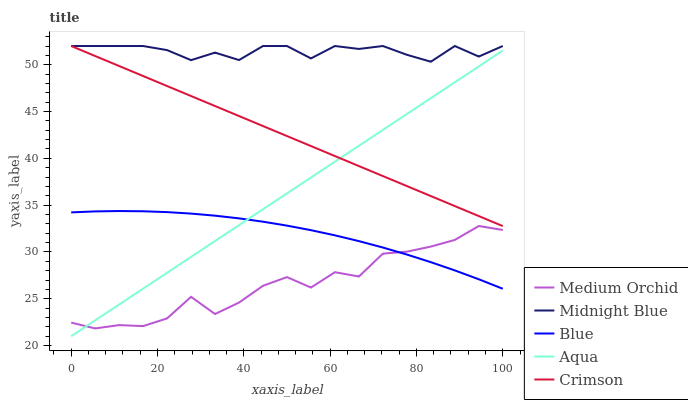Does Crimson have the minimum area under the curve?
Answer yes or no. No. Does Crimson have the maximum area under the curve?
Answer yes or no. No. Is Medium Orchid the smoothest?
Answer yes or no. No. Is Crimson the roughest?
Answer yes or no. No. Does Crimson have the lowest value?
Answer yes or no. No. Does Medium Orchid have the highest value?
Answer yes or no. No. Is Medium Orchid less than Midnight Blue?
Answer yes or no. Yes. Is Midnight Blue greater than Blue?
Answer yes or no. Yes. Does Medium Orchid intersect Midnight Blue?
Answer yes or no. No. 